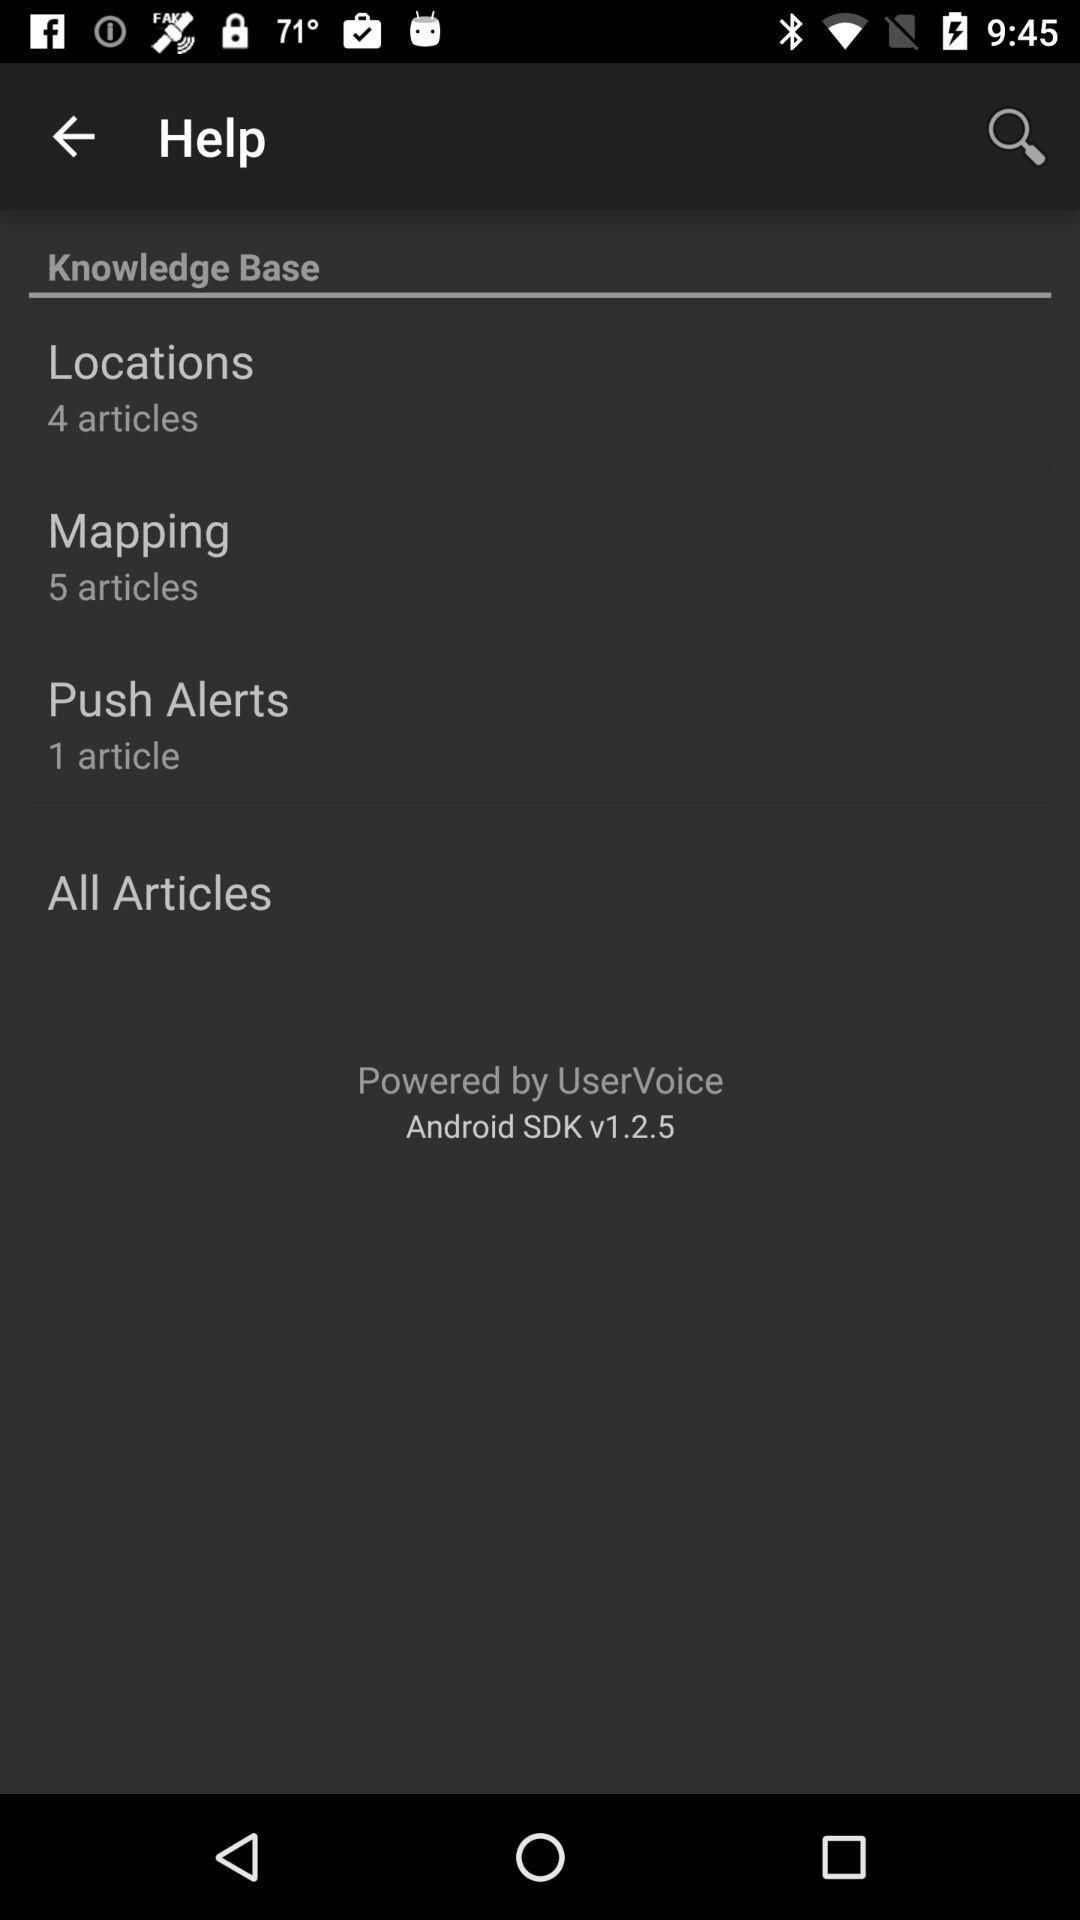How many articles are there in total?
Answer the question using a single word or phrase. 10 